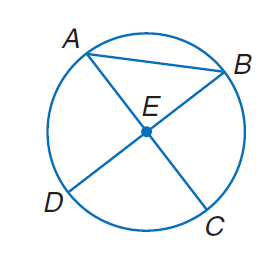Answer the mathemtical geometry problem and directly provide the correct option letter.
Question: Suppose B D = 12 millimeters. Find the radius of the circle.
Choices: A: 6 B: 12 C: 18 D: 36 A 